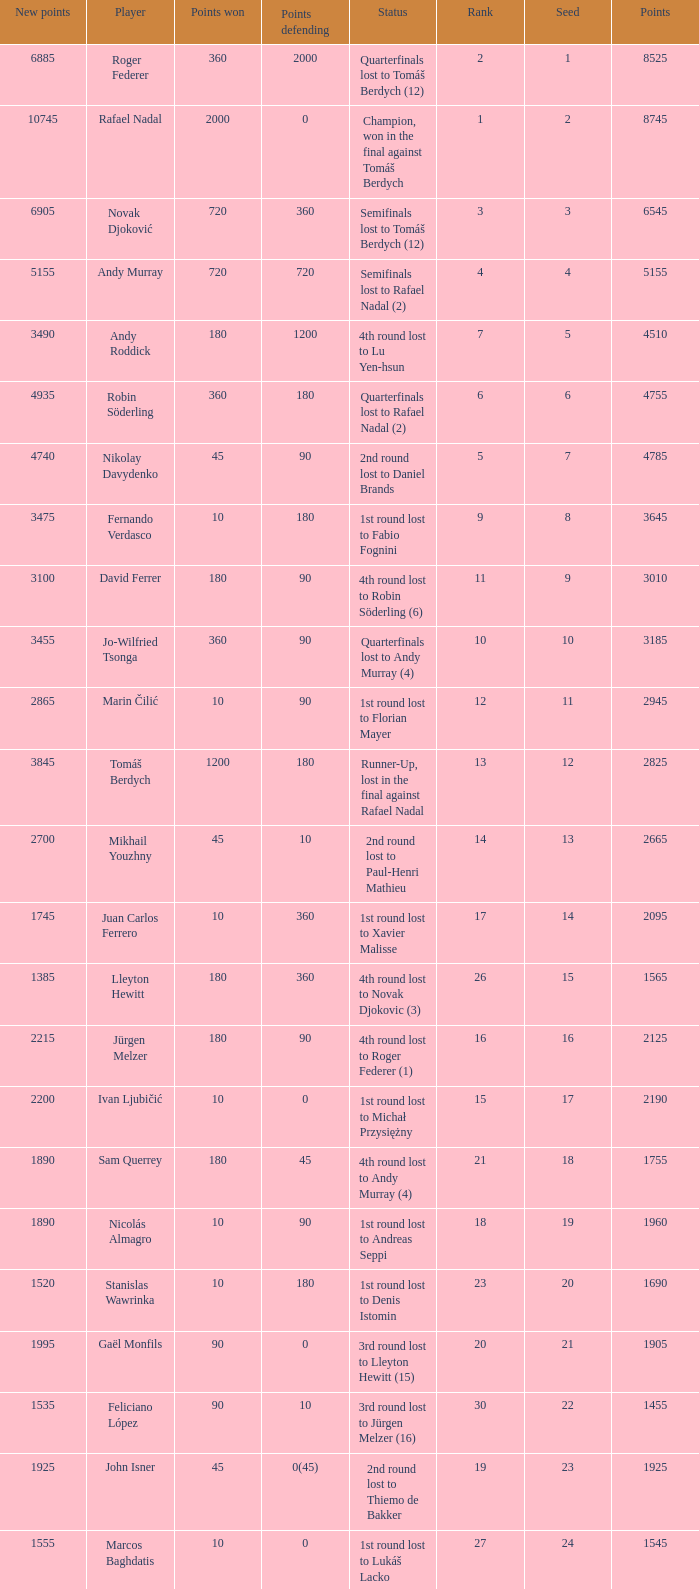Name the least new points for points defending is 1200 3490.0. 